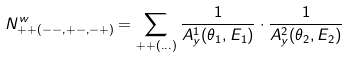<formula> <loc_0><loc_0><loc_500><loc_500>N ^ { w } _ { + + ( - - , + - , - + ) } = \sum _ { + + ( \dots ) } \frac { 1 } { A ^ { 1 } _ { y } ( \theta _ { 1 } , E _ { 1 } ) } \cdot \frac { 1 } { A ^ { 2 } _ { y } ( \theta _ { 2 } , E _ { 2 } ) }</formula> 